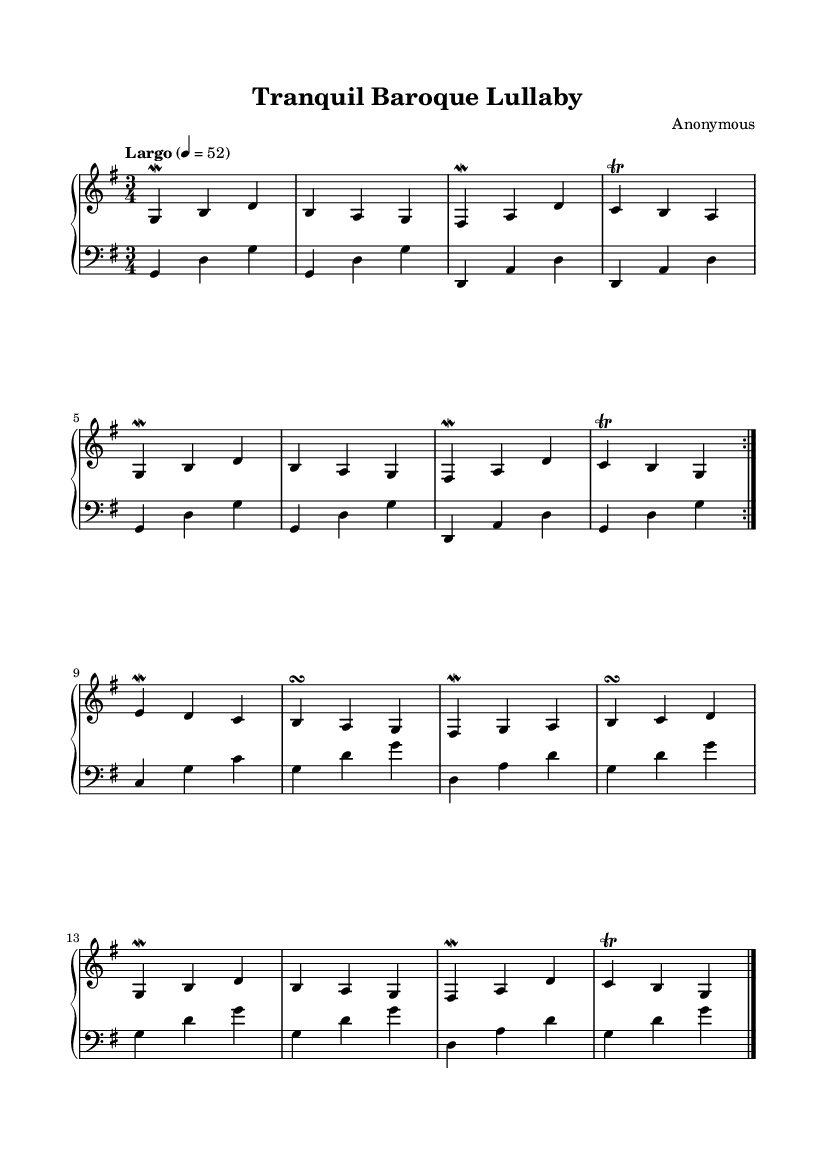What is the key signature of this music? The key signature has one sharp, which indicates it is in G major. The corresponding notes are F# for the key signature, which can be identified at the beginning of the staff.
Answer: G major What is the time signature of this piece? The time signature at the beginning of the score is indicated by the symbols associated with the measures, showing that there are three beats per measure. The "3/4" indicates it's a waltz-like structure with a strong first beat.
Answer: 3/4 What is the tempo marking for the piece? The tempo marking on the score states "Largo," with a metronome marking of quarter note = 52. This indicates the music should be played slowly and gently.
Answer: Largo How many times is the main melody repeated? Looking at the repeat sign (volta) indicated in the melody section, it specifies that the melody section should be played two times before moving on.
Answer: 2 What type of ornamentation is frequently used in the melody? The score shows frequent use of ornaments such as mordents and trills, which are specific forms of embellishments typical in Baroque music, enhancing the expressiveness of the melody.
Answer: Mordents and trills What is the texture of the music based on the instruments involved? The score includes two staves: one for the right hand playing melody and one for the left hand playing harmony, indicating a homophonic texture typical of Baroque keyboard music.
Answer: Homophonic What musical era does this piece belong to? The use of specific ornamentation styles, the structure, and the instrumentation suggest that this piece exemplifies the characteristics of the Baroque era, known for its elaborate musical techniques and forms.
Answer: Baroque 